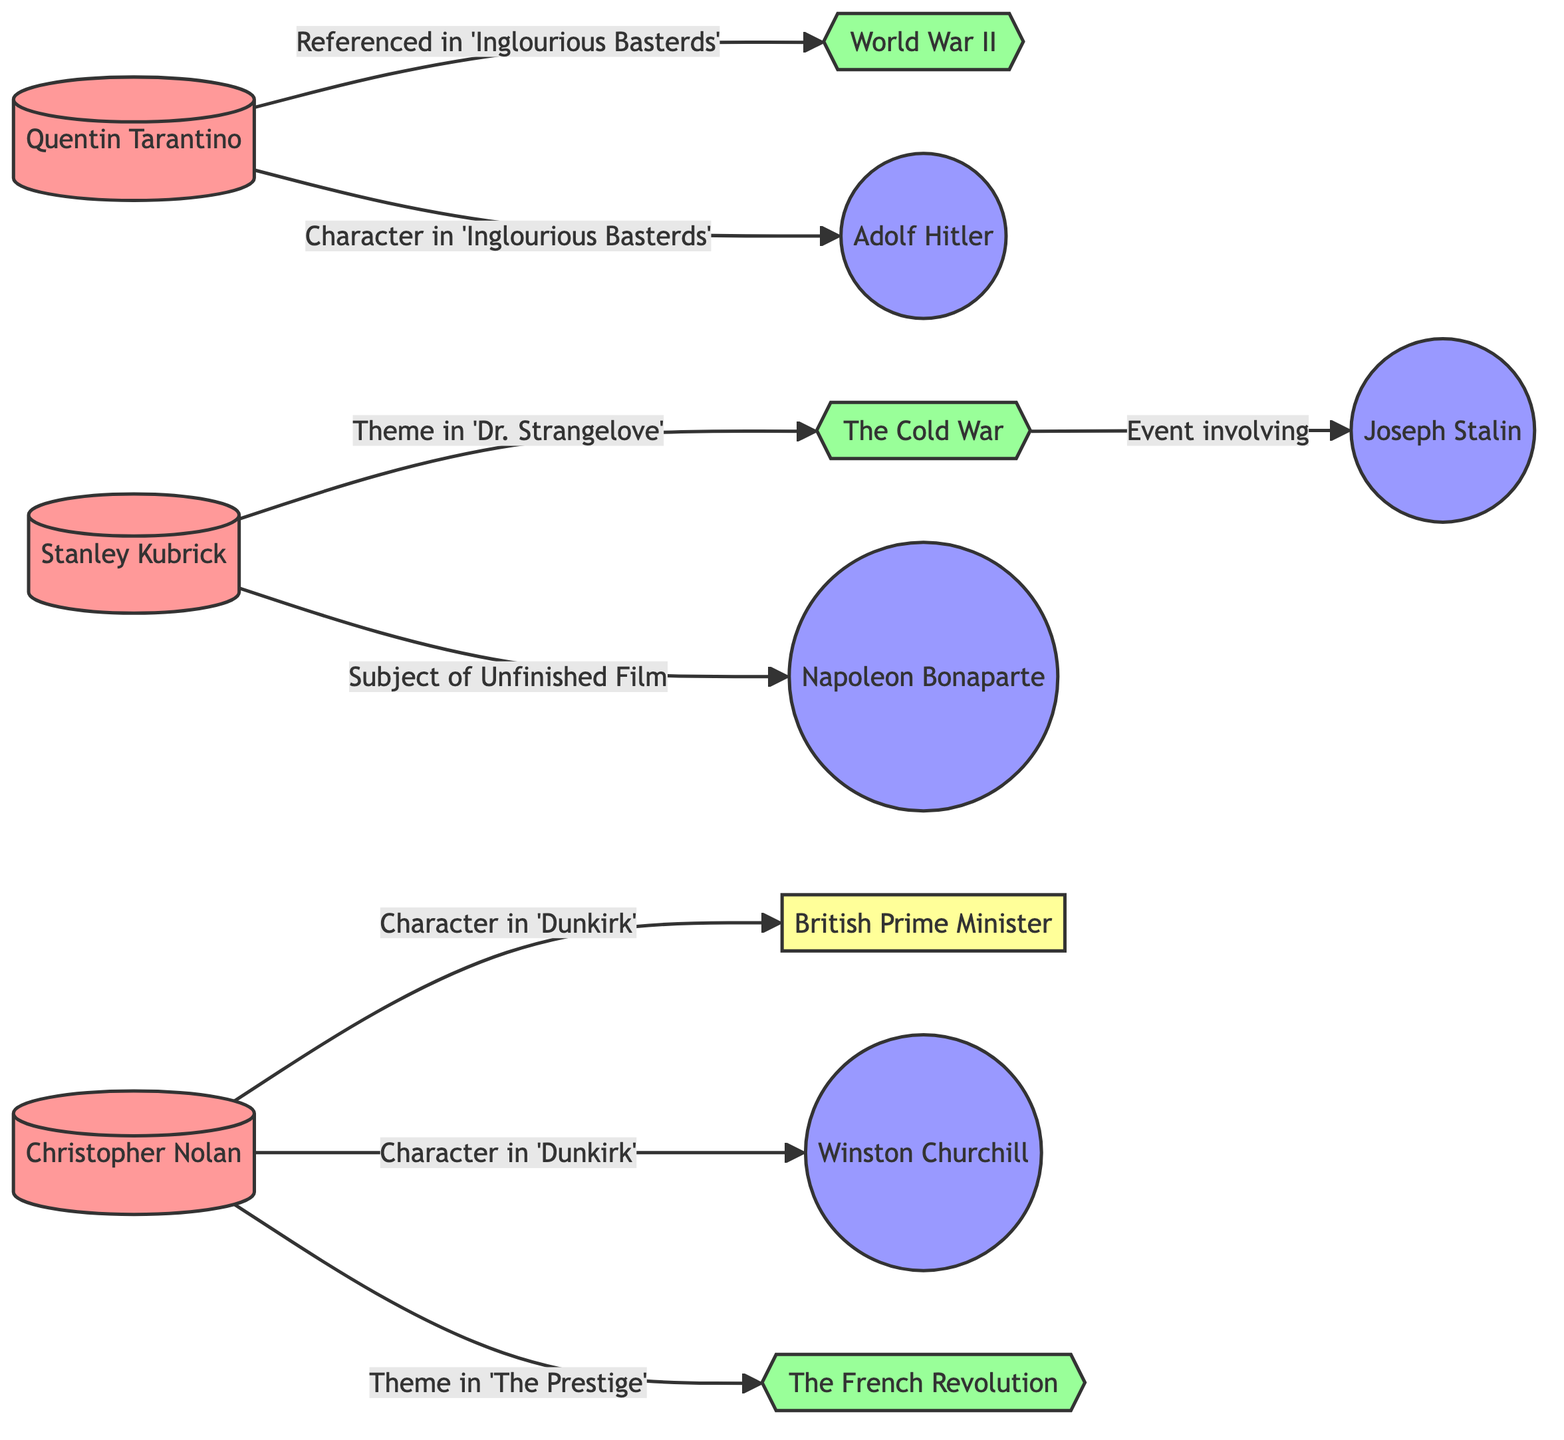What is the thematic connection of Stanley Kubrick's work? The theme connected to Stanley Kubrick's work is "The Cold War," as shown in the edge labeled "Theme in 'Dr. Strangelove'."
Answer: The Cold War Who directed "Dunkirk"? "Dunkirk" is directed by Christopher Nolan, indicated by the node labeled "Christopher Nolan."
Answer: Christopher Nolan Which historical figure is referenced in "Inglourious Basterds"? The historical figure referenced in "Inglourious Basterds" is Adolf Hitler, as shown in the edge labeled "Character in 'Inglourious Basterds'."
Answer: Adolf Hitler How many directors are represented in the diagram? There are three directors represented in the diagram: Quentin Tarantino, Stanley Kubrick, and Christopher Nolan.
Answer: 3 What event is linked to Joseph Stalin? The event linked to Joseph Stalin is "The Cold War," which is shown in the edge labeled "Event involving 'Joseph Stalin'."
Answer: The Cold War What is the relationship between Christopher Nolan and Winston Churchill? The relationship is that Winston Churchill is a character in Christopher Nolan's film "Dunkirk," as indicated by the edge labeled "Character in 'Dunkirk'."
Answer: Character in 'Dunkirk' Which historical figure is linked to Napoleon Bonaparte? Napoleon Bonaparte is linked to Stanley Kubrick, as indicated by the edge labeled "Subject of Unfinished Film."
Answer: Stanley Kubrick What is the total number of historical figures mentioned? There are five historical figures mentioned: Adolf Hitler, Napoleon Bonaparte, Winston Churchill, Joseph Stalin, and the British Prime Minister.
Answer: 5 What connects Quentin Tarantino to World War II? Quentin Tarantino is connected to World War II through the film "Inglourious Basterds," as shown in the edge labeled "Referenced in 'Inglourious Basterds'."
Answer: Referenced in 'Inglourious Basterds' 